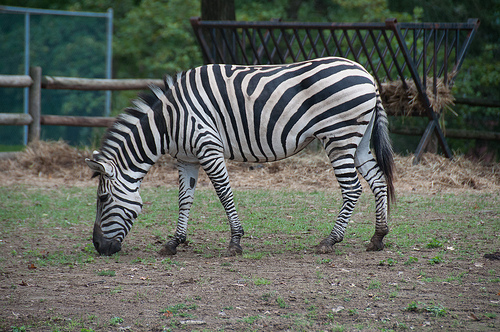Please provide a short description for this region: [0.31, 0.64, 0.39, 0.69]. The region shows a zebra's hoof, notably dirty and grey, suggesting recent movement in muddy or dusty conditions. 